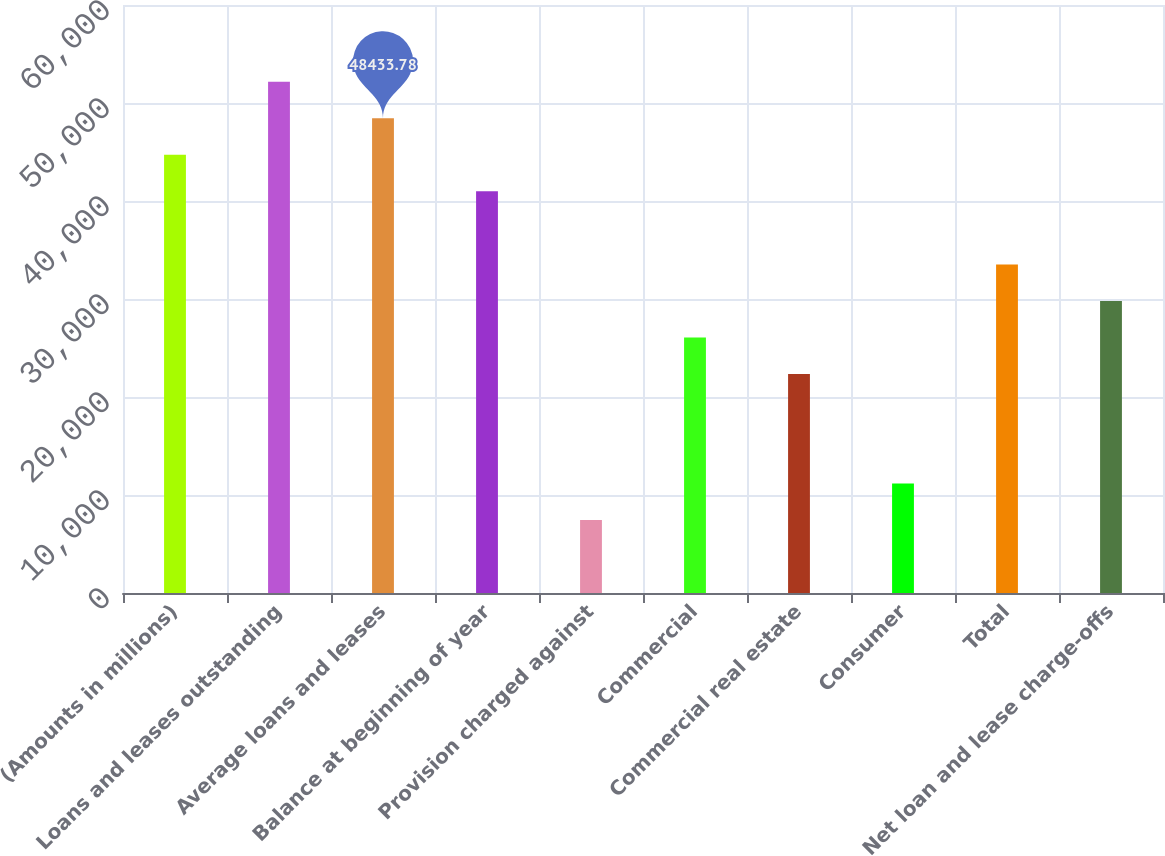Convert chart to OTSL. <chart><loc_0><loc_0><loc_500><loc_500><bar_chart><fcel>(Amounts in millions)<fcel>Loans and leases outstanding<fcel>Average loans and leases<fcel>Balance at beginning of year<fcel>Provision charged against<fcel>Commercial<fcel>Commercial real estate<fcel>Consumer<fcel>Total<fcel>Net loan and lease charge-offs<nl><fcel>44708.2<fcel>52159.4<fcel>48433.8<fcel>40982.6<fcel>7452.4<fcel>26080.3<fcel>22354.7<fcel>11178<fcel>33531.5<fcel>29805.9<nl></chart> 